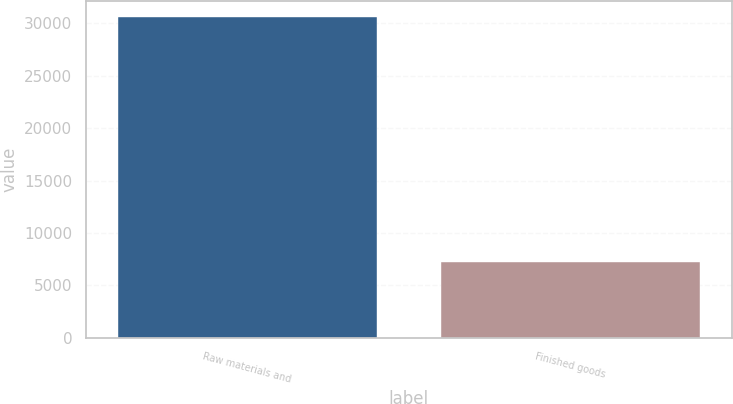<chart> <loc_0><loc_0><loc_500><loc_500><bar_chart><fcel>Raw materials and<fcel>Finished goods<nl><fcel>30637<fcel>7218<nl></chart> 